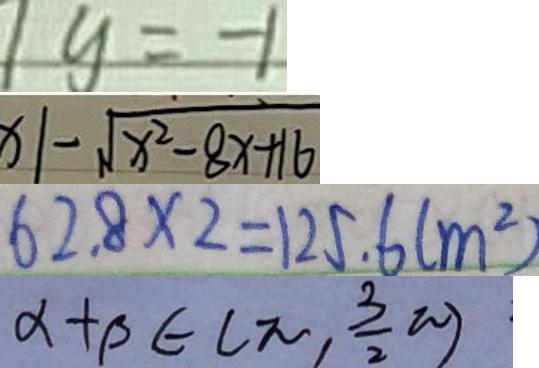Convert formula to latex. <formula><loc_0><loc_0><loc_500><loc_500>1 y = - 1 
 x \vert - \sqrt { x ^ { 2 } - 8 x + 1 6 } 
 6 2 . 8 \times 2 = 1 2 5 . 6 ( m ^ { 2 } ) 
 \alpha + \beta \in ( \pi , \frac { 3 } { 2 } \pi )</formula> 